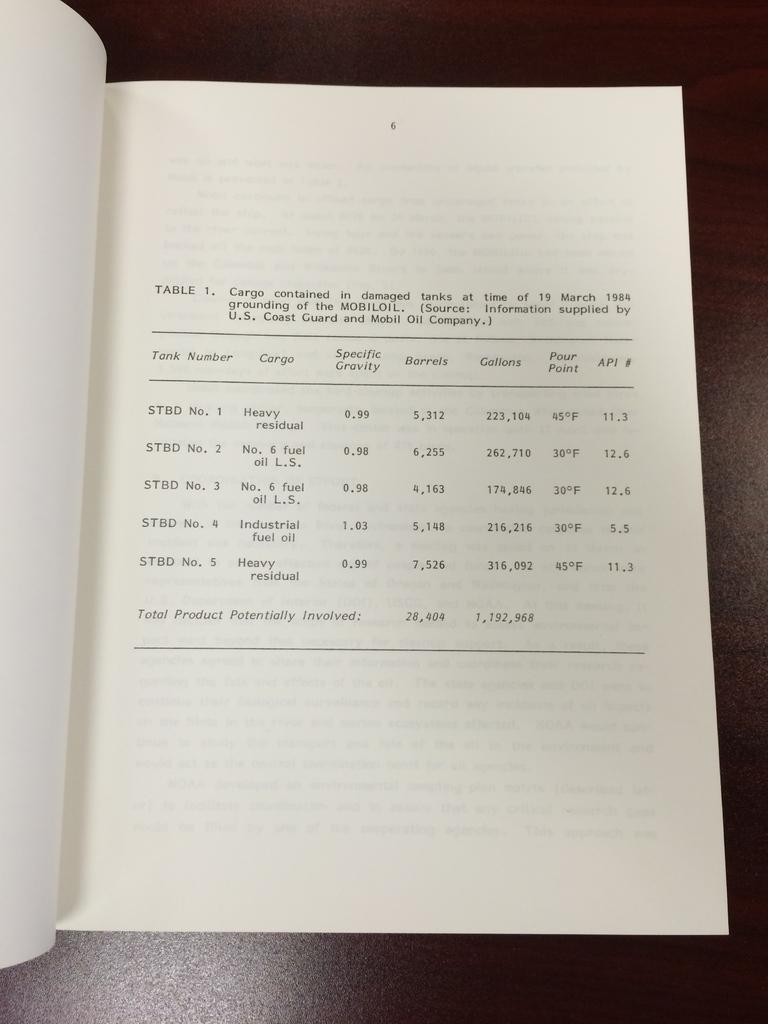<image>
Present a compact description of the photo's key features. A book with a report of cargo is displayed 